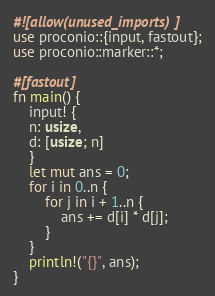<code> <loc_0><loc_0><loc_500><loc_500><_Rust_>#![allow(unused_imports)]
use proconio::{input, fastout};
use proconio::marker::*;

#[fastout]
fn main() {
    input! {
    n: usize,
    d: [usize; n]
    }
    let mut ans = 0;
    for i in 0..n {
        for j in i + 1..n {
            ans += d[i] * d[j];
        }
    }
    println!("{}", ans);
}
</code> 